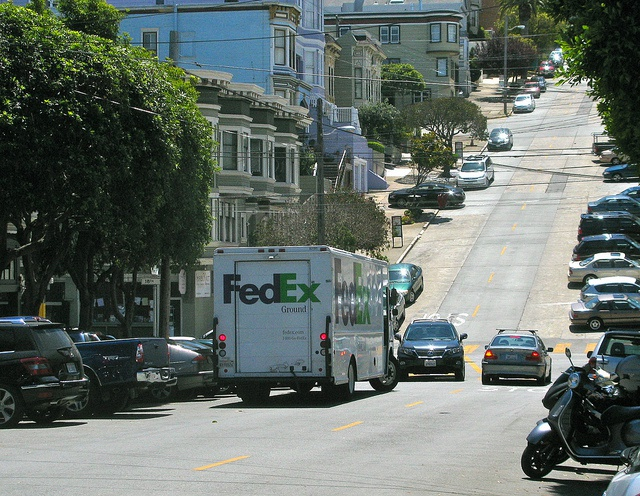Describe the objects in this image and their specific colors. I can see truck in gray and black tones, car in gray, black, purple, and lightgray tones, car in gray, black, and purple tones, motorcycle in gray, black, blue, and darkblue tones, and truck in gray, black, blue, and darkgray tones in this image. 